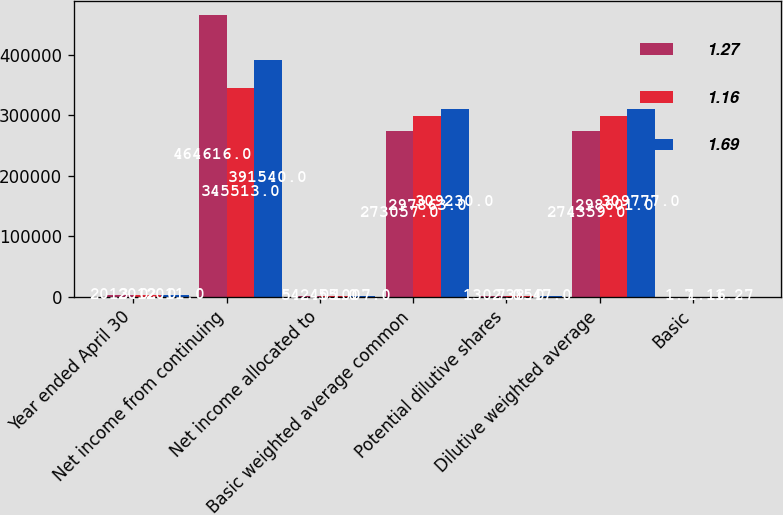Convert chart. <chart><loc_0><loc_0><loc_500><loc_500><stacked_bar_chart><ecel><fcel>Year ended April 30<fcel>Net income from continuing<fcel>Net income allocated to<fcel>Basic weighted average common<fcel>Potential dilutive shares<fcel>Dilutive weighted average<fcel>Basic<nl><fcel>1.27<fcel>2013<fcel>464616<fcel>542<fcel>273057<fcel>1302<fcel>274359<fcel>1.7<nl><fcel>1.16<fcel>2012<fcel>345513<fcel>455<fcel>297863<fcel>738<fcel>298601<fcel>1.16<nl><fcel>1.69<fcel>2011<fcel>391540<fcel>1007<fcel>309230<fcel>547<fcel>309777<fcel>1.27<nl></chart> 